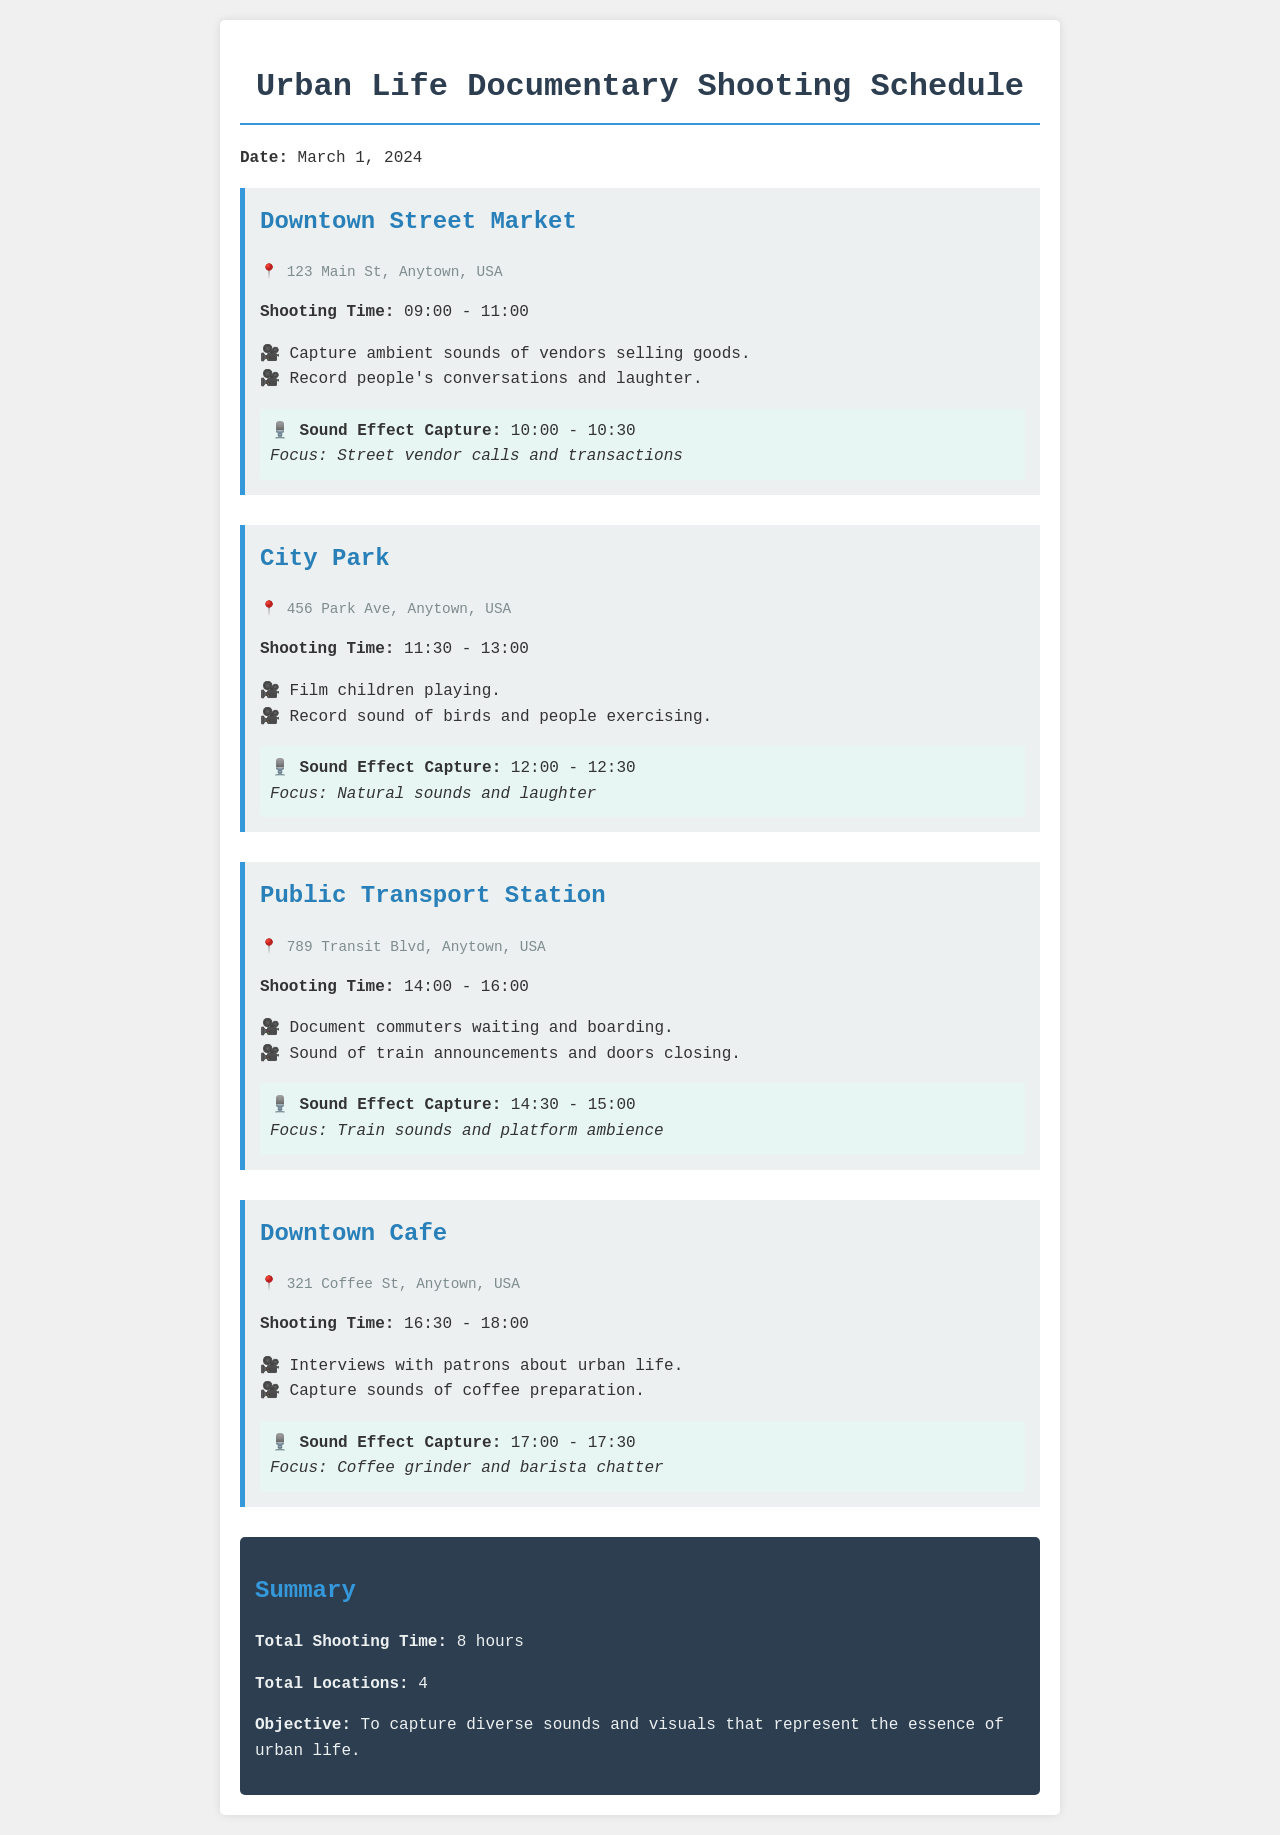What is the shooting time at Downtown Street Market? The shooting time at Downtown Street Market is mentioned in the document as 09:00 - 11:00.
Answer: 09:00 - 11:00 What sound effect will be captured at City Park? The sound effect capture session at City Park will focus on natural sounds and laughter as noted in the document.
Answer: Natural sounds and laughter How many locations are listed in the shooting schedule? The total number of locations can be found in the summary of the document, which states there are 4 locations in total.
Answer: 4 What is the address of the Public Transport Station? The address for the Public Transport Station is given as 789 Transit Blvd, Anytown, USA in the document.
Answer: 789 Transit Blvd, Anytown, USA What time is the sound effect capture at Downtown Cafe? The sound effect capture session at Downtown Cafe is scheduled from 17:00 to 17:30 as outlined in the location details.
Answer: 17:00 - 17:30 Which location has activities that include capturing ambient sounds of vendors? The activities related to capturing ambient sounds of vendors are specified for the Downtown Street Market in the document.
Answer: Downtown Street Market What is the total shooting time for the entire schedule? The document summarizes that the total shooting time is 8 hours across all the scheduled locations.
Answer: 8 hours At what time does shooting start at City Park? The document states that shooting starts at City Park at 11:30.
Answer: 11:30 